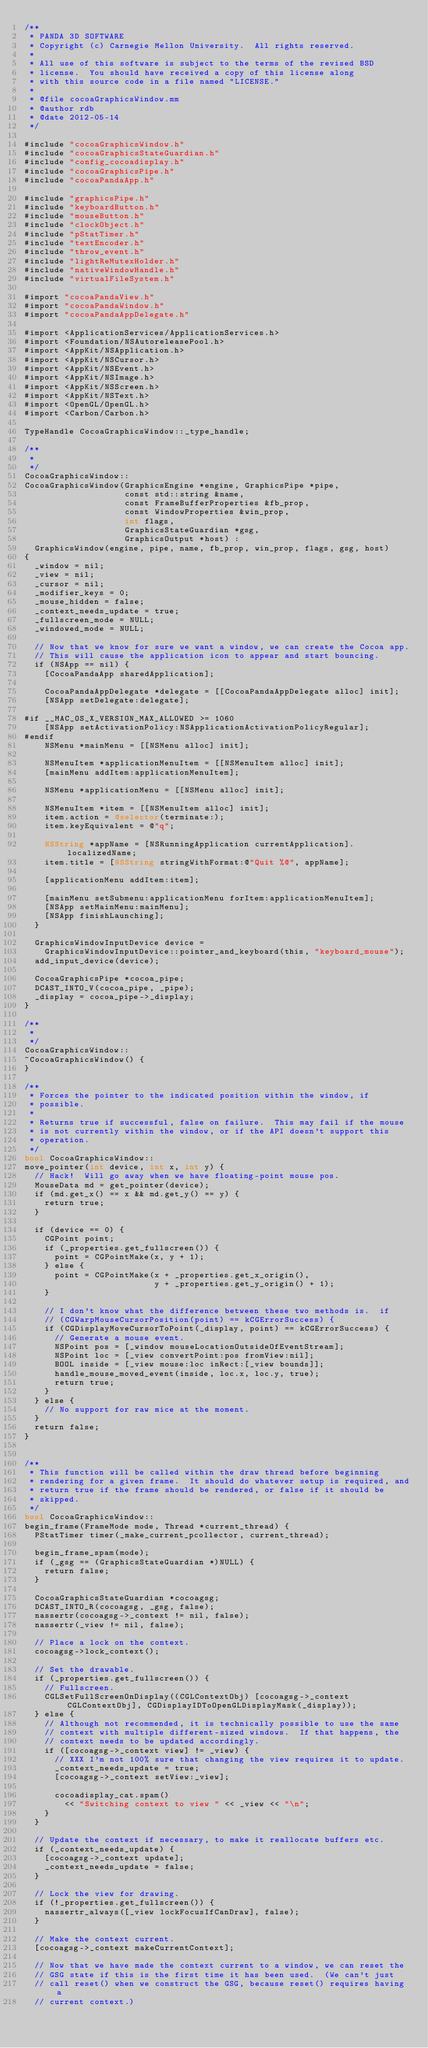Convert code to text. <code><loc_0><loc_0><loc_500><loc_500><_ObjectiveC_>/**
 * PANDA 3D SOFTWARE
 * Copyright (c) Carnegie Mellon University.  All rights reserved.
 *
 * All use of this software is subject to the terms of the revised BSD
 * license.  You should have received a copy of this license along
 * with this source code in a file named "LICENSE."
 *
 * @file cocoaGraphicsWindow.mm
 * @author rdb
 * @date 2012-05-14
 */

#include "cocoaGraphicsWindow.h"
#include "cocoaGraphicsStateGuardian.h"
#include "config_cocoadisplay.h"
#include "cocoaGraphicsPipe.h"
#include "cocoaPandaApp.h"

#include "graphicsPipe.h"
#include "keyboardButton.h"
#include "mouseButton.h"
#include "clockObject.h"
#include "pStatTimer.h"
#include "textEncoder.h"
#include "throw_event.h"
#include "lightReMutexHolder.h"
#include "nativeWindowHandle.h"
#include "virtualFileSystem.h"

#import "cocoaPandaView.h"
#import "cocoaPandaWindow.h"
#import "cocoaPandaAppDelegate.h"

#import <ApplicationServices/ApplicationServices.h>
#import <Foundation/NSAutoreleasePool.h>
#import <AppKit/NSApplication.h>
#import <AppKit/NSCursor.h>
#import <AppKit/NSEvent.h>
#import <AppKit/NSImage.h>
#import <AppKit/NSScreen.h>
#import <AppKit/NSText.h>
#import <OpenGL/OpenGL.h>
#import <Carbon/Carbon.h>

TypeHandle CocoaGraphicsWindow::_type_handle;

/**
 *
 */
CocoaGraphicsWindow::
CocoaGraphicsWindow(GraphicsEngine *engine, GraphicsPipe *pipe,
                    const std::string &name,
                    const FrameBufferProperties &fb_prop,
                    const WindowProperties &win_prop,
                    int flags,
                    GraphicsStateGuardian *gsg,
                    GraphicsOutput *host) :
  GraphicsWindow(engine, pipe, name, fb_prop, win_prop, flags, gsg, host)
{
  _window = nil;
  _view = nil;
  _cursor = nil;
  _modifier_keys = 0;
  _mouse_hidden = false;
  _context_needs_update = true;
  _fullscreen_mode = NULL;
  _windowed_mode = NULL;

  // Now that we know for sure we want a window, we can create the Cocoa app.
  // This will cause the application icon to appear and start bouncing.
  if (NSApp == nil) {
    [CocoaPandaApp sharedApplication];

    CocoaPandaAppDelegate *delegate = [[CocoaPandaAppDelegate alloc] init];
    [NSApp setDelegate:delegate];

#if __MAC_OS_X_VERSION_MAX_ALLOWED >= 1060
    [NSApp setActivationPolicy:NSApplicationActivationPolicyRegular];
#endif
    NSMenu *mainMenu = [[NSMenu alloc] init];

    NSMenuItem *applicationMenuItem = [[NSMenuItem alloc] init];
    [mainMenu addItem:applicationMenuItem];

    NSMenu *applicationMenu = [[NSMenu alloc] init];

    NSMenuItem *item = [[NSMenuItem alloc] init];
    item.action = @selector(terminate:);
    item.keyEquivalent = @"q";

    NSString *appName = [NSRunningApplication currentApplication].localizedName;
    item.title = [NSString stringWithFormat:@"Quit %@", appName];

    [applicationMenu addItem:item];

    [mainMenu setSubmenu:applicationMenu forItem:applicationMenuItem];
    [NSApp setMainMenu:mainMenu];
    [NSApp finishLaunching];
  }

  GraphicsWindowInputDevice device =
    GraphicsWindowInputDevice::pointer_and_keyboard(this, "keyboard_mouse");
  add_input_device(device);

  CocoaGraphicsPipe *cocoa_pipe;
  DCAST_INTO_V(cocoa_pipe, _pipe);
  _display = cocoa_pipe->_display;
}

/**
 *
 */
CocoaGraphicsWindow::
~CocoaGraphicsWindow() {
}

/**
 * Forces the pointer to the indicated position within the window, if
 * possible.
 *
 * Returns true if successful, false on failure.  This may fail if the mouse
 * is not currently within the window, or if the API doesn't support this
 * operation.
 */
bool CocoaGraphicsWindow::
move_pointer(int device, int x, int y) {
  // Hack!  Will go away when we have floating-point mouse pos.
  MouseData md = get_pointer(device);
  if (md.get_x() == x && md.get_y() == y) {
    return true;
  }

  if (device == 0) {
    CGPoint point;
    if (_properties.get_fullscreen()) {
      point = CGPointMake(x, y + 1);
    } else {
      point = CGPointMake(x + _properties.get_x_origin(),
                          y + _properties.get_y_origin() + 1);
    }

    // I don't know what the difference between these two methods is.  if
    // (CGWarpMouseCursorPosition(point) == kCGErrorSuccess) {
    if (CGDisplayMoveCursorToPoint(_display, point) == kCGErrorSuccess) {
      // Generate a mouse event.
      NSPoint pos = [_window mouseLocationOutsideOfEventStream];
      NSPoint loc = [_view convertPoint:pos fromView:nil];
      BOOL inside = [_view mouse:loc inRect:[_view bounds]];
      handle_mouse_moved_event(inside, loc.x, loc.y, true);
      return true;
    }
  } else {
    // No support for raw mice at the moment.
  }
  return false;
}


/**
 * This function will be called within the draw thread before beginning
 * rendering for a given frame.  It should do whatever setup is required, and
 * return true if the frame should be rendered, or false if it should be
 * skipped.
 */
bool CocoaGraphicsWindow::
begin_frame(FrameMode mode, Thread *current_thread) {
  PStatTimer timer(_make_current_pcollector, current_thread);

  begin_frame_spam(mode);
  if (_gsg == (GraphicsStateGuardian *)NULL) {
    return false;
  }

  CocoaGraphicsStateGuardian *cocoagsg;
  DCAST_INTO_R(cocoagsg, _gsg, false);
  nassertr(cocoagsg->_context != nil, false);
  nassertr(_view != nil, false);

  // Place a lock on the context.
  cocoagsg->lock_context();

  // Set the drawable.
  if (_properties.get_fullscreen()) {
    // Fullscreen.
    CGLSetFullScreenOnDisplay((CGLContextObj) [cocoagsg->_context CGLContextObj], CGDisplayIDToOpenGLDisplayMask(_display));
  } else {
    // Although not recommended, it is technically possible to use the same
    // context with multiple different-sized windows.  If that happens, the
    // context needs to be updated accordingly.
    if ([cocoagsg->_context view] != _view) {
      // XXX I'm not 100% sure that changing the view requires it to update.
      _context_needs_update = true;
      [cocoagsg->_context setView:_view];

      cocoadisplay_cat.spam()
        << "Switching context to view " << _view << "\n";
    }
  }

  // Update the context if necessary, to make it reallocate buffers etc.
  if (_context_needs_update) {
    [cocoagsg->_context update];
    _context_needs_update = false;
  }

  // Lock the view for drawing.
  if (!_properties.get_fullscreen()) {
    nassertr_always([_view lockFocusIfCanDraw], false);
  }

  // Make the context current.
  [cocoagsg->_context makeCurrentContext];

  // Now that we have made the context current to a window, we can reset the
  // GSG state if this is the first time it has been used.  (We can't just
  // call reset() when we construct the GSG, because reset() requires having a
  // current context.)</code> 